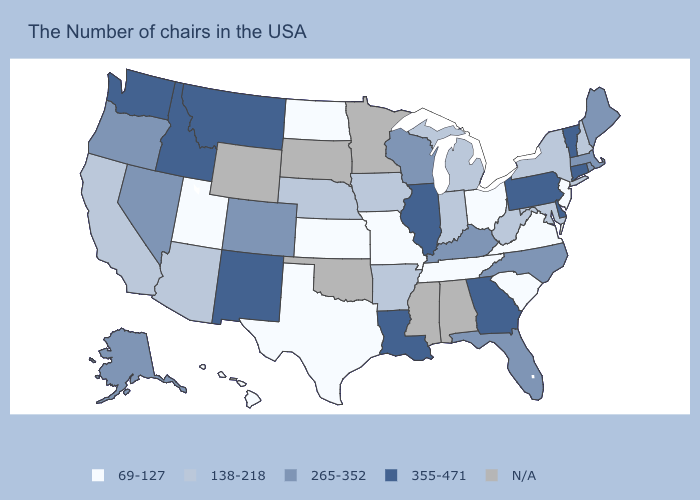Which states hav the highest value in the Northeast?
Give a very brief answer. Vermont, Connecticut, Pennsylvania. Among the states that border Rhode Island , does Connecticut have the lowest value?
Keep it brief. No. How many symbols are there in the legend?
Concise answer only. 5. Name the states that have a value in the range 265-352?
Keep it brief. Maine, Massachusetts, Rhode Island, North Carolina, Florida, Kentucky, Wisconsin, Colorado, Nevada, Oregon, Alaska. Is the legend a continuous bar?
Write a very short answer. No. What is the value of Florida?
Give a very brief answer. 265-352. Name the states that have a value in the range 138-218?
Be succinct. New Hampshire, New York, Maryland, West Virginia, Michigan, Indiana, Arkansas, Iowa, Nebraska, Arizona, California. Name the states that have a value in the range 69-127?
Write a very short answer. New Jersey, Virginia, South Carolina, Ohio, Tennessee, Missouri, Kansas, Texas, North Dakota, Utah, Hawaii. Name the states that have a value in the range 138-218?
Give a very brief answer. New Hampshire, New York, Maryland, West Virginia, Michigan, Indiana, Arkansas, Iowa, Nebraska, Arizona, California. Name the states that have a value in the range 138-218?
Be succinct. New Hampshire, New York, Maryland, West Virginia, Michigan, Indiana, Arkansas, Iowa, Nebraska, Arizona, California. What is the lowest value in the USA?
Be succinct. 69-127. What is the value of New Jersey?
Write a very short answer. 69-127. Which states have the lowest value in the USA?
Answer briefly. New Jersey, Virginia, South Carolina, Ohio, Tennessee, Missouri, Kansas, Texas, North Dakota, Utah, Hawaii. 